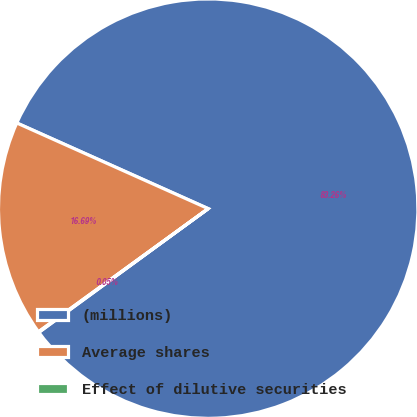Convert chart to OTSL. <chart><loc_0><loc_0><loc_500><loc_500><pie_chart><fcel>(millions)<fcel>Average shares<fcel>Effect of dilutive securities<nl><fcel>83.26%<fcel>16.69%<fcel>0.05%<nl></chart> 